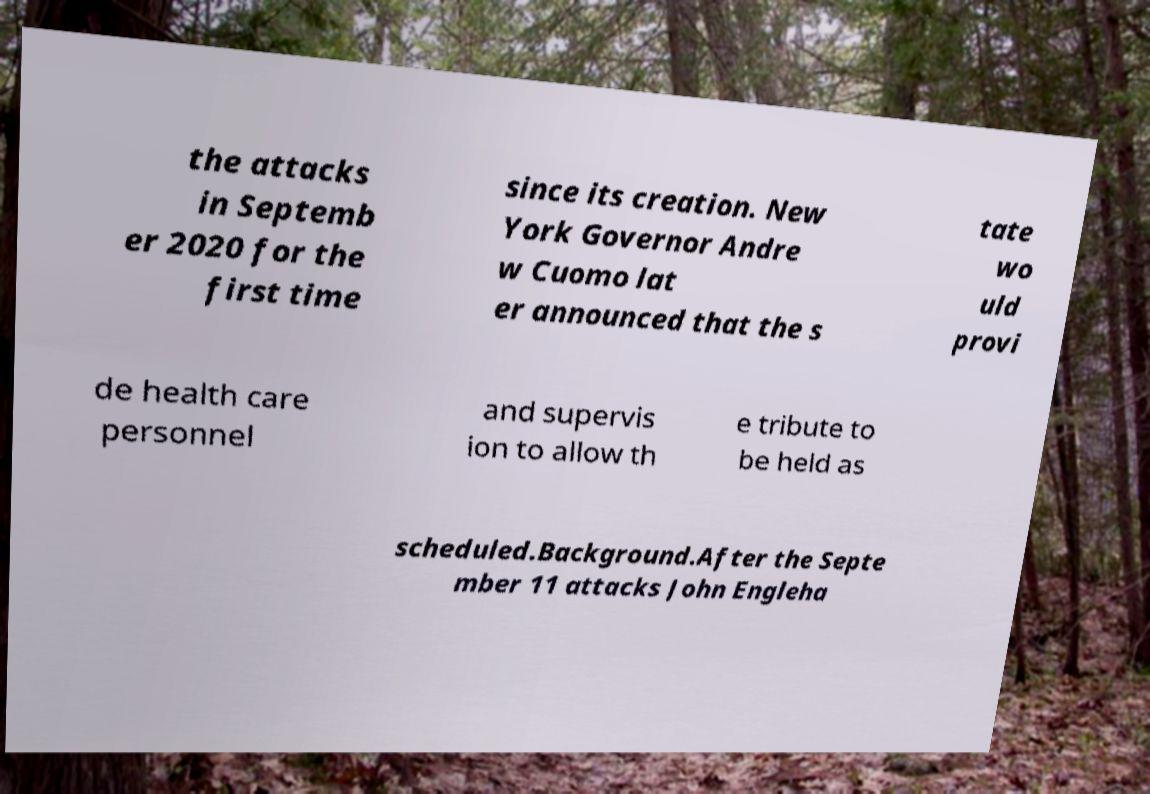What messages or text are displayed in this image? I need them in a readable, typed format. the attacks in Septemb er 2020 for the first time since its creation. New York Governor Andre w Cuomo lat er announced that the s tate wo uld provi de health care personnel and supervis ion to allow th e tribute to be held as scheduled.Background.After the Septe mber 11 attacks John Engleha 